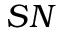Convert formula to latex. <formula><loc_0><loc_0><loc_500><loc_500>S N</formula> 